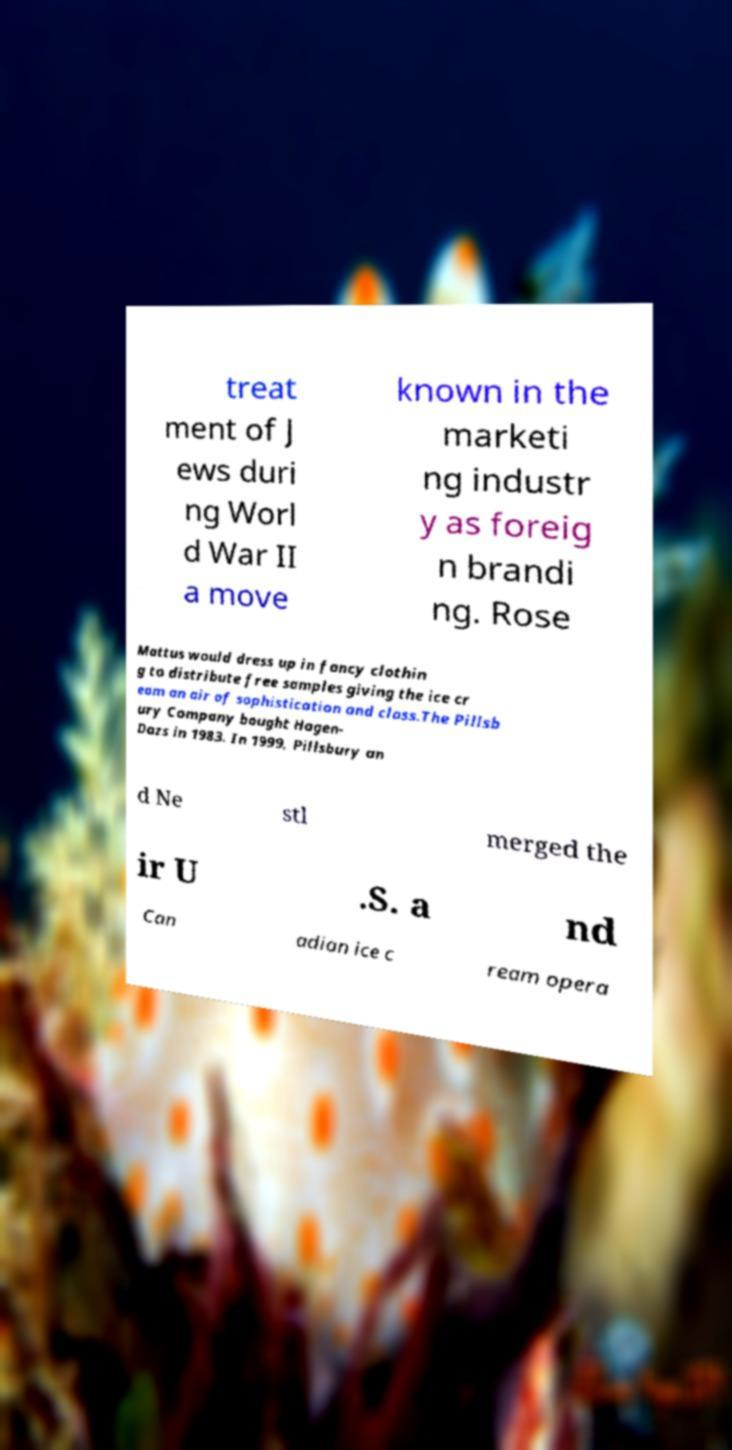Could you extract and type out the text from this image? treat ment of J ews duri ng Worl d War II a move known in the marketi ng industr y as foreig n brandi ng. Rose Mattus would dress up in fancy clothin g to distribute free samples giving the ice cr eam an air of sophistication and class.The Pillsb ury Company bought Hagen- Dazs in 1983. In 1999, Pillsbury an d Ne stl merged the ir U .S. a nd Can adian ice c ream opera 